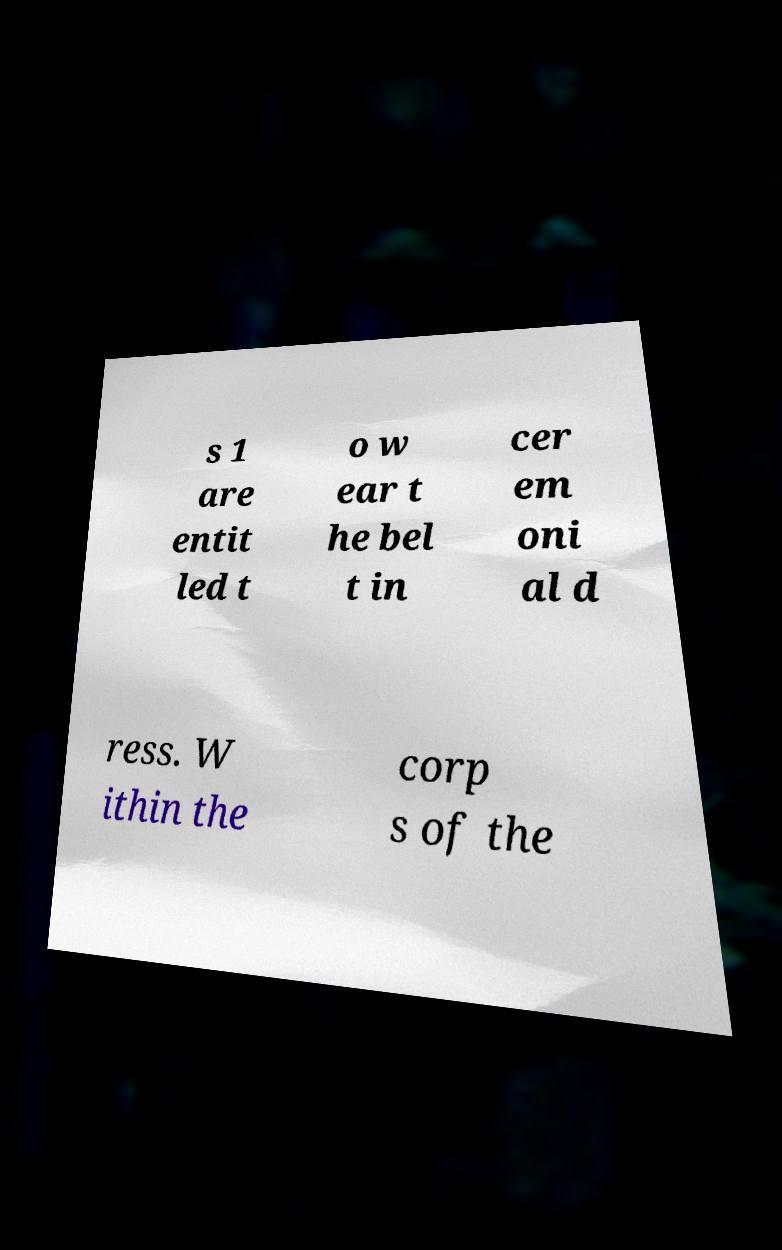Please read and relay the text visible in this image. What does it say? s 1 are entit led t o w ear t he bel t in cer em oni al d ress. W ithin the corp s of the 